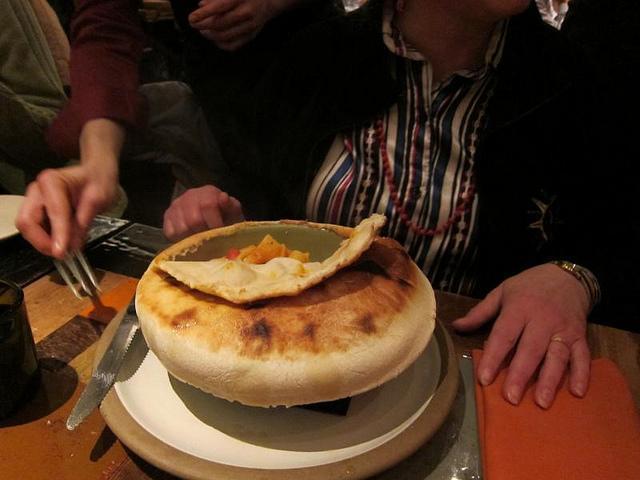How many people can you see?
Give a very brief answer. 2. 